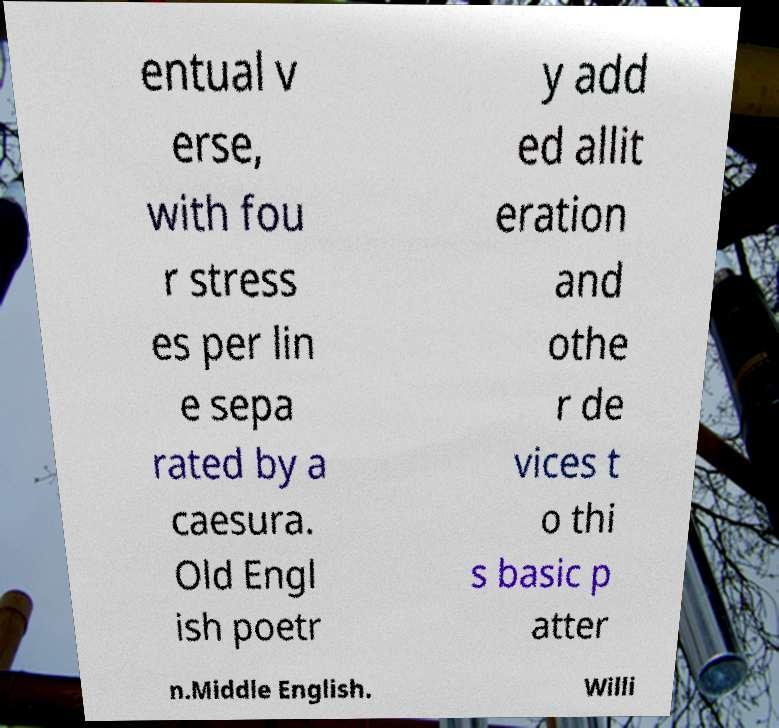For documentation purposes, I need the text within this image transcribed. Could you provide that? entual v erse, with fou r stress es per lin e sepa rated by a caesura. Old Engl ish poetr y add ed allit eration and othe r de vices t o thi s basic p atter n.Middle English. Willi 